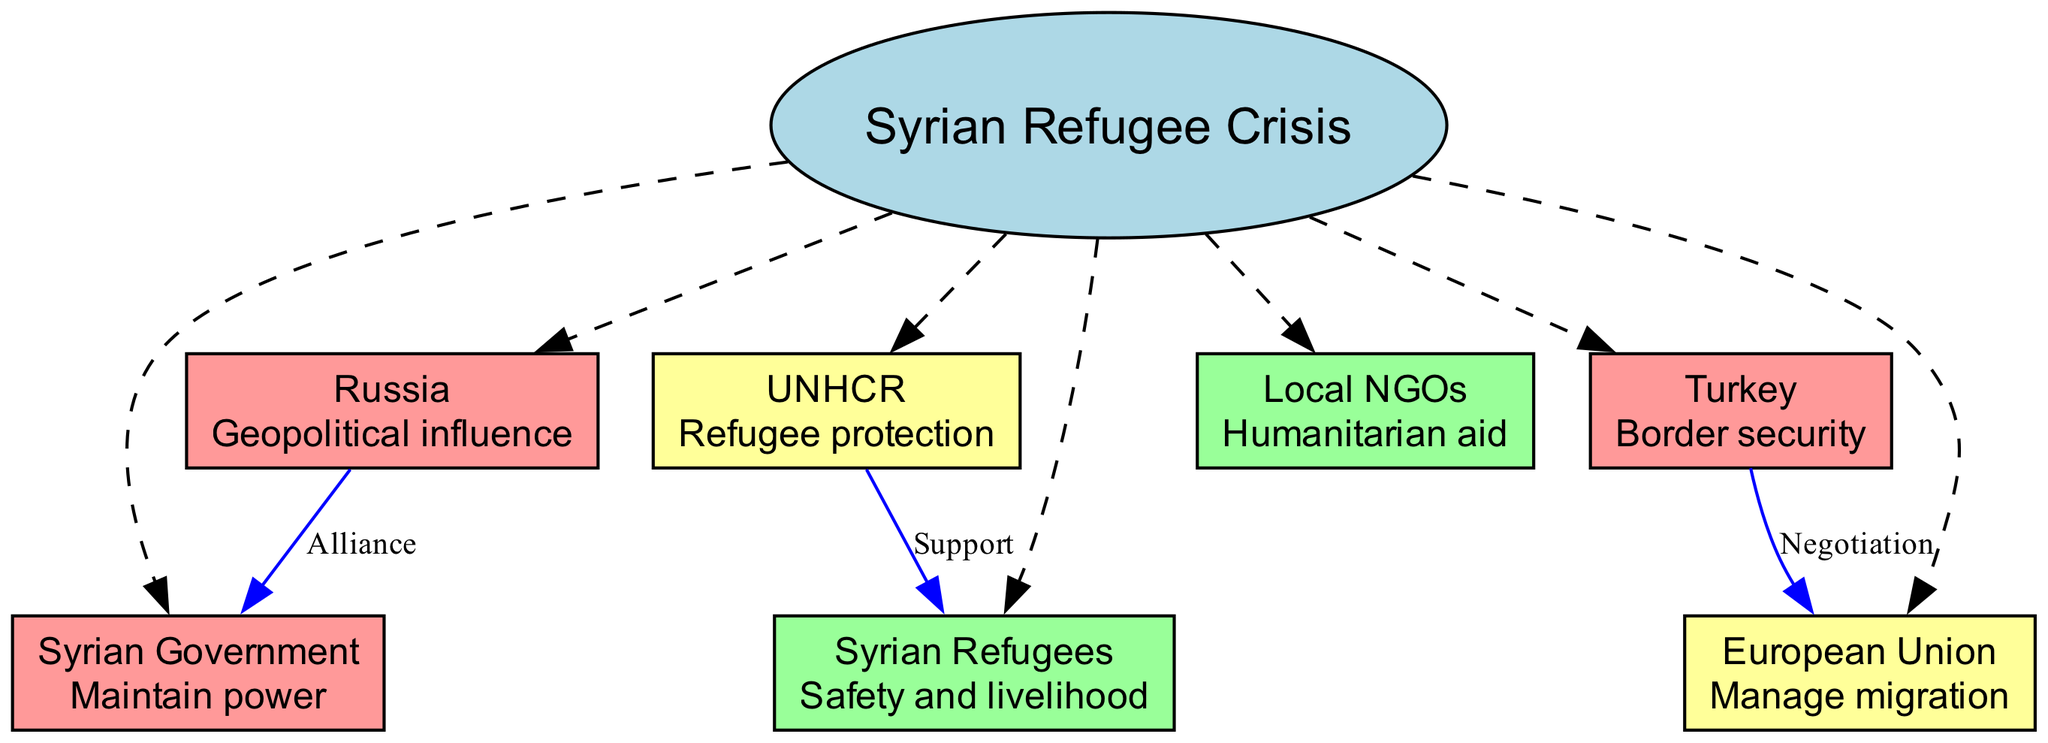What is the central topic of the diagram? The title or central theme of the diagram is explicitly mentioned in the central node labeled "Central".
Answer: Syrian Refugee Crisis How many stakeholders are represented in the diagram? Counting the nodes that represent stakeholders in the diagram gives a total of 7 distinct stakeholders.
Answer: 7 What interest does the UNHCR have? The interest of the UNHCR is indicated within its respective node, which explicitly states "Refugee protection".
Answer: Refugee protection What type of relationship exists between Turkey and the European Union? The edge connecting Turkey to the European Union specifies the relationship type as "Negotiation".
Answer: Negotiation Which stakeholder has a high level of influence and an interest in geopolitical influence? By examining the nodes, Russia is identified as having a "High" influence level and expressing an interest in "Geopolitical influence".
Answer: Russia How many relationships involve support? Reviewing the relationships, there is one that specifies a type of "Support", which is between UNHCR and Syrian Refugees.
Answer: 1 Which stakeholder has low influence and is primarily focused on humanitarian aid? Analyzing the stakeholders, Local NGOs is shown to have "Low" influence, with the interest listed as "Humanitarian aid".
Answer: Local NGOs Which actor is allied with the Syrian Government? The diagram indicates that Russia has an alliance with the Syrian Government, as shown by the relationship labeled "Alliance".
Answer: Russia How many stakeholders are seeking safety and livelihood? Only the Syrian Refugees stakeholder has their interest defined as seeking "Safety and livelihood".
Answer: 1 What interest does Turkey have? The interest indicated for Turkey is explicitly stated as "Border security" within its node.
Answer: Border security 